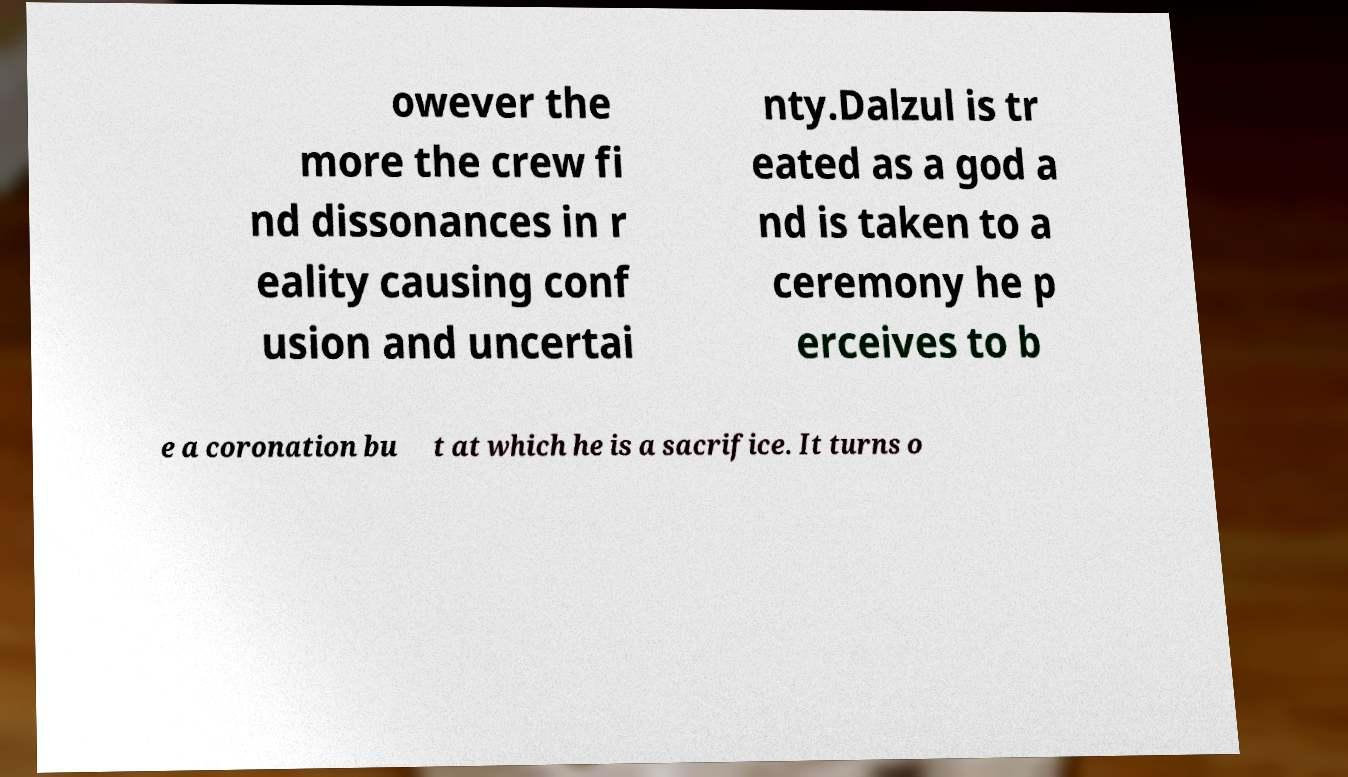Could you extract and type out the text from this image? owever the more the crew fi nd dissonances in r eality causing conf usion and uncertai nty.Dalzul is tr eated as a god a nd is taken to a ceremony he p erceives to b e a coronation bu t at which he is a sacrifice. It turns o 